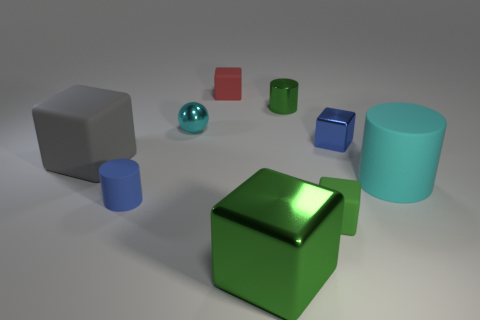Subtract all blue cubes. How many cubes are left? 4 Subtract all green blocks. How many blocks are left? 3 Add 1 gray things. How many objects exist? 10 Subtract 2 cylinders. How many cylinders are left? 1 Subtract all spheres. How many objects are left? 8 Subtract all small cylinders. Subtract all blue rubber cylinders. How many objects are left? 6 Add 1 small green cubes. How many small green cubes are left? 2 Add 2 small shiny things. How many small shiny things exist? 5 Subtract 0 blue balls. How many objects are left? 9 Subtract all brown cylinders. Subtract all cyan balls. How many cylinders are left? 3 